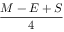Convert formula to latex. <formula><loc_0><loc_0><loc_500><loc_500>\frac { M - E + S } { 4 }</formula> 